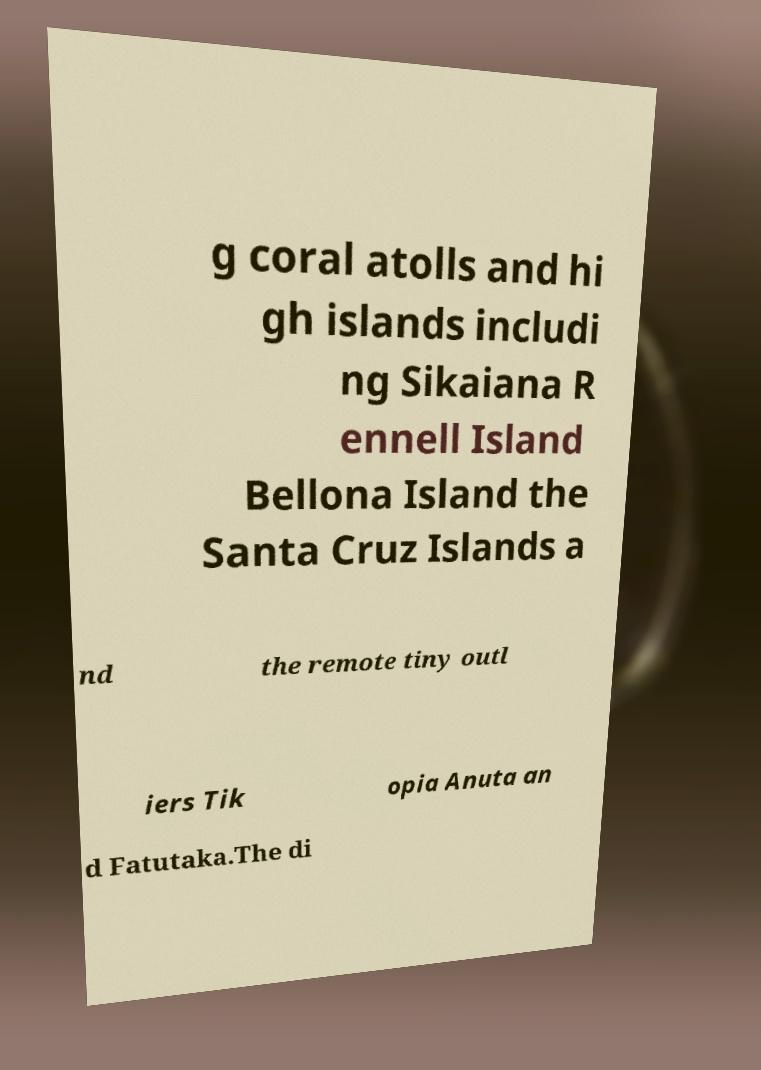What messages or text are displayed in this image? I need them in a readable, typed format. g coral atolls and hi gh islands includi ng Sikaiana R ennell Island Bellona Island the Santa Cruz Islands a nd the remote tiny outl iers Tik opia Anuta an d Fatutaka.The di 